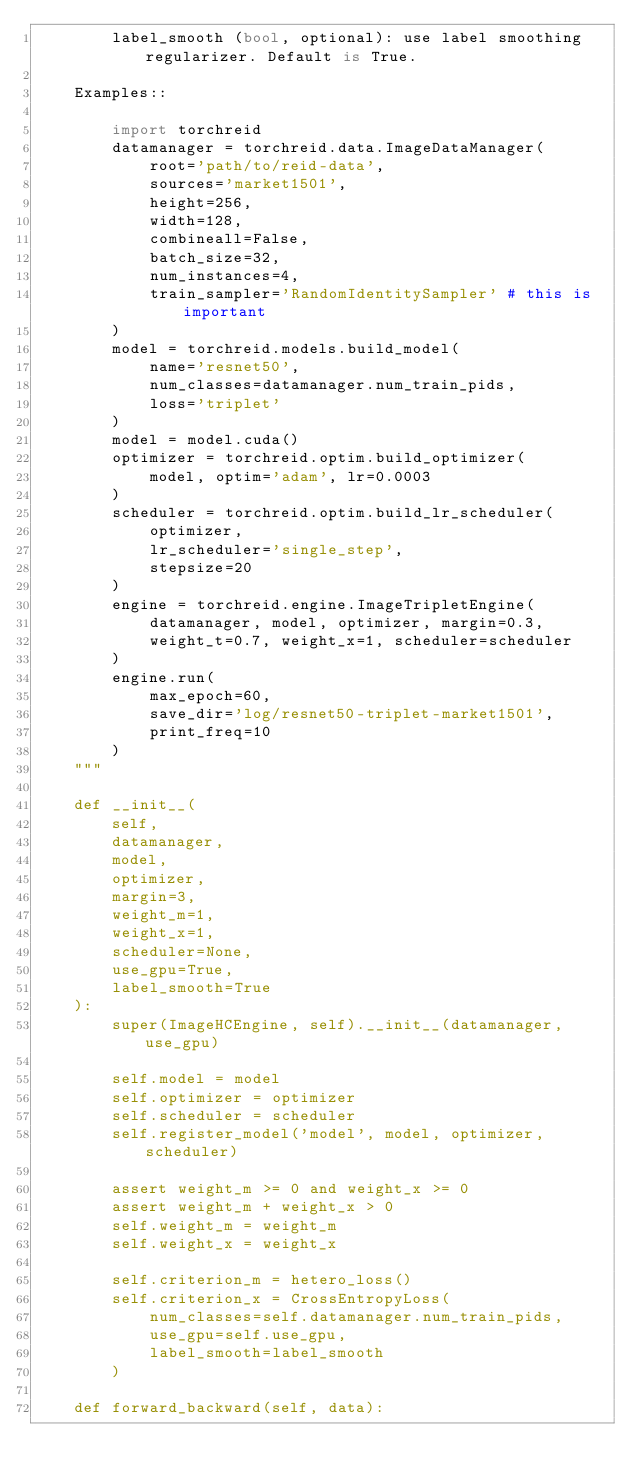Convert code to text. <code><loc_0><loc_0><loc_500><loc_500><_Python_>        label_smooth (bool, optional): use label smoothing regularizer. Default is True.

    Examples::
        
        import torchreid
        datamanager = torchreid.data.ImageDataManager(
            root='path/to/reid-data',
            sources='market1501',
            height=256,
            width=128,
            combineall=False,
            batch_size=32,
            num_instances=4,
            train_sampler='RandomIdentitySampler' # this is important
        )
        model = torchreid.models.build_model(
            name='resnet50',
            num_classes=datamanager.num_train_pids,
            loss='triplet'
        )
        model = model.cuda()
        optimizer = torchreid.optim.build_optimizer(
            model, optim='adam', lr=0.0003
        )
        scheduler = torchreid.optim.build_lr_scheduler(
            optimizer,
            lr_scheduler='single_step',
            stepsize=20
        )
        engine = torchreid.engine.ImageTripletEngine(
            datamanager, model, optimizer, margin=0.3,
            weight_t=0.7, weight_x=1, scheduler=scheduler
        )
        engine.run(
            max_epoch=60,
            save_dir='log/resnet50-triplet-market1501',
            print_freq=10
        )
    """

    def __init__(
        self,
        datamanager,
        model,
        optimizer,
        margin=3,
        weight_m=1,
        weight_x=1,
        scheduler=None,
        use_gpu=True,
        label_smooth=True
    ):
        super(ImageHCEngine, self).__init__(datamanager, use_gpu)

        self.model = model
        self.optimizer = optimizer
        self.scheduler = scheduler
        self.register_model('model', model, optimizer, scheduler)

        assert weight_m >= 0 and weight_x >= 0
        assert weight_m + weight_x > 0
        self.weight_m = weight_m
        self.weight_x = weight_x

        self.criterion_m = hetero_loss()
        self.criterion_x = CrossEntropyLoss(
            num_classes=self.datamanager.num_train_pids,
            use_gpu=self.use_gpu,
            label_smooth=label_smooth
        )

    def forward_backward(self, data):</code> 